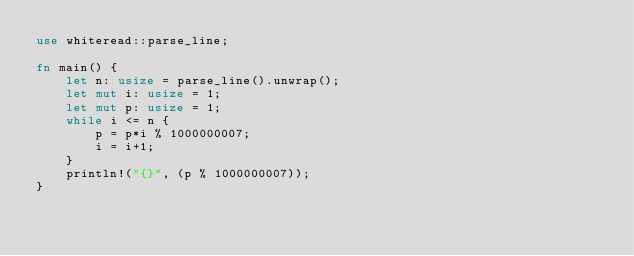Convert code to text. <code><loc_0><loc_0><loc_500><loc_500><_Rust_>use whiteread::parse_line;

fn main() {
    let n: usize = parse_line().unwrap();
    let mut i: usize = 1;
    let mut p: usize = 1;
    while i <= n {
        p = p*i % 1000000007;
        i = i+1;
    }
    println!("{}", (p % 1000000007));
}
</code> 